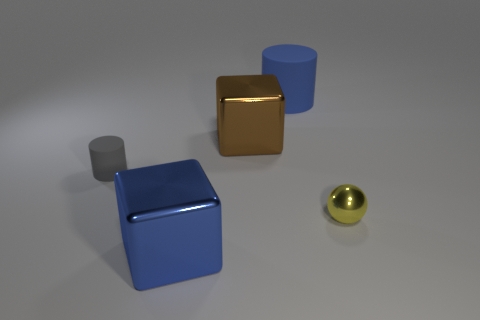Add 4 small cyan metal objects. How many objects exist? 9 Subtract all gray cylinders. How many cylinders are left? 1 Add 5 small cyan metallic spheres. How many small cyan metallic spheres exist? 5 Subtract 1 blue cylinders. How many objects are left? 4 Subtract all spheres. How many objects are left? 4 Subtract 1 blocks. How many blocks are left? 1 Subtract all red cubes. Subtract all brown cylinders. How many cubes are left? 2 Subtract all purple spheres. How many brown blocks are left? 1 Subtract all cyan cylinders. Subtract all small gray things. How many objects are left? 4 Add 1 tiny gray objects. How many tiny gray objects are left? 2 